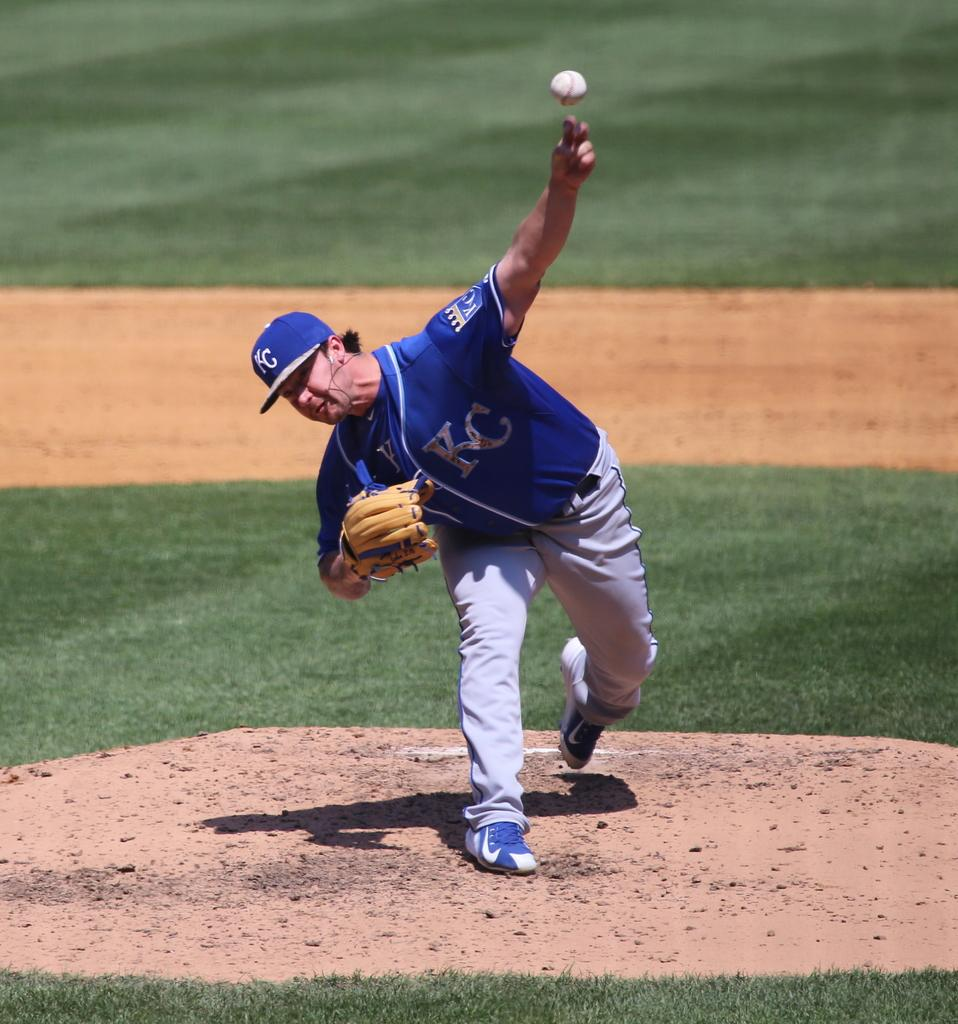<image>
Provide a brief description of the given image. A man in a Kansas City Royals jersey is standing on a pitching mound, getting ready to throw a baseball. 